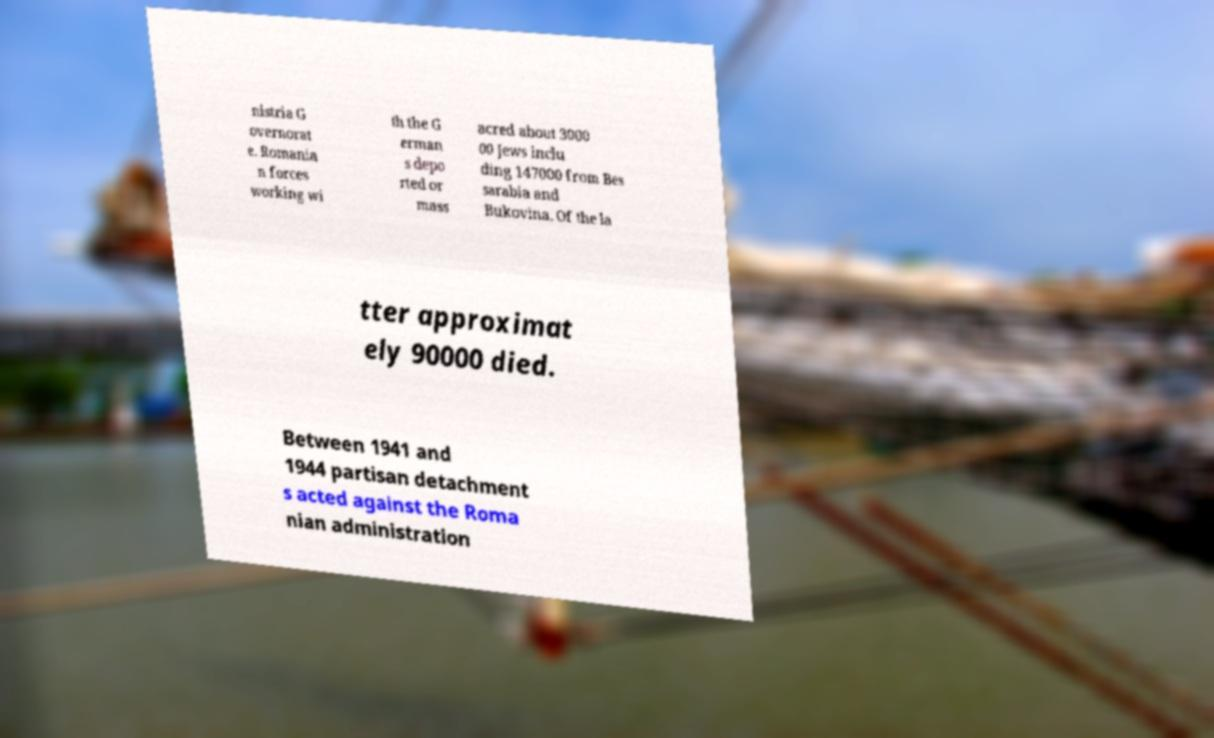I need the written content from this picture converted into text. Can you do that? nistria G overnorat e. Romania n forces working wi th the G erman s depo rted or mass acred about 3000 00 Jews inclu ding 147000 from Bes sarabia and Bukovina. Of the la tter approximat ely 90000 died. Between 1941 and 1944 partisan detachment s acted against the Roma nian administration 